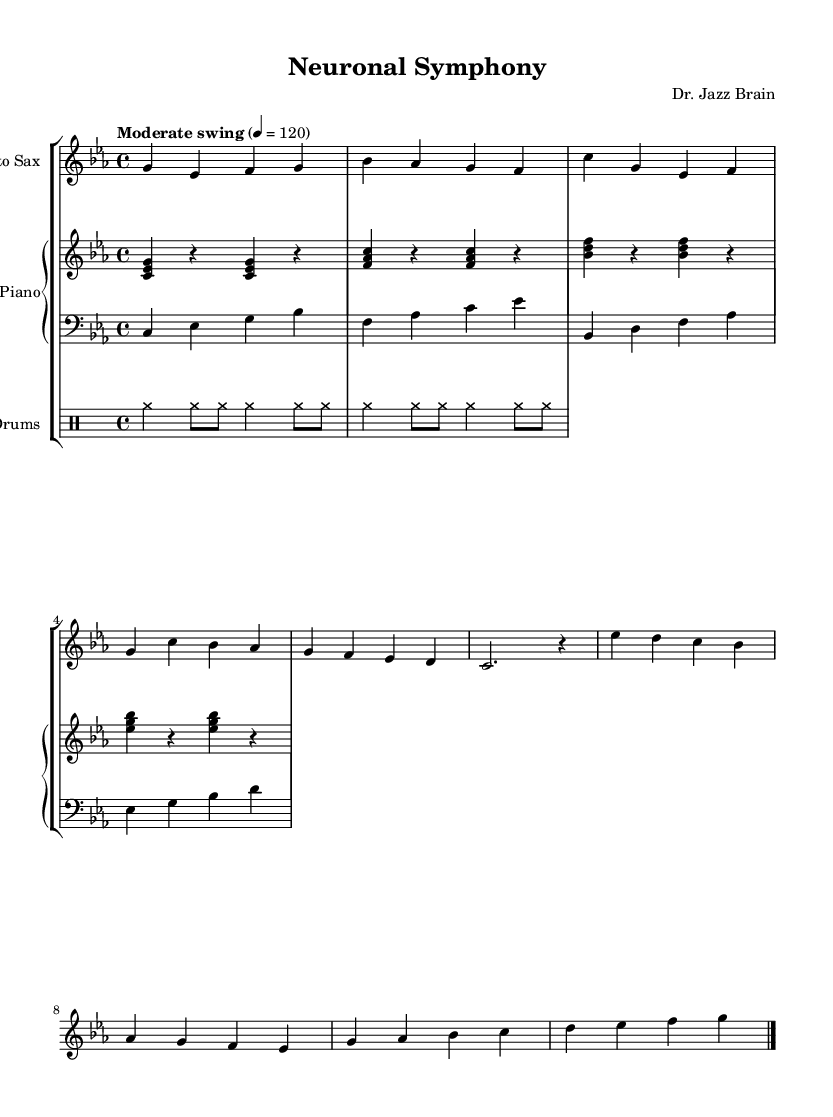What is the key signature of this music? The key signature is C minor, which has three flats (B flat, E flat, and A flat). This is indicated at the beginning of the staff with the flat symbols present.
Answer: C minor What is the time signature of this piece? The time signature is 4/4, denoted by the "4" over the "4" at the beginning of the music. This indicates that there are four beats in a measure, and the quarter note gets one beat.
Answer: 4/4 What is the tempo marking for this piece? The tempo marking indicated is "Moderate swing," with a metronome marking of 120 beats per minute. This suggests a relaxed and groovy swing feel in a moderate pace.
Answer: Moderate swing What instruments are featured in this score? The score features Alto Sax, Piano, Bass, and Drums, as indicated by the names provided in the respective staff groupings.
Answer: Alto Sax, Piano, Bass, Drums How many sections are in the melody? The melody consists of two sections identified as the A Section and the B Section, which are common in jazz compositions for creating variations and contrasts.
Answer: Two sections What is the style of accompaniment used in the piano part? The piano part uses a "comping" style, which provides harmonic support and rhythmic complexity, common in jazz to enhance the overall texture.
Answer: Comping What rhythmic pattern is used in the drum section? The drum section employs a standard jazz ride pattern, indicated by the notation in the drum staff, which features continuous cymbal hits to maintain the swing feel.
Answer: Jazz ride pattern 